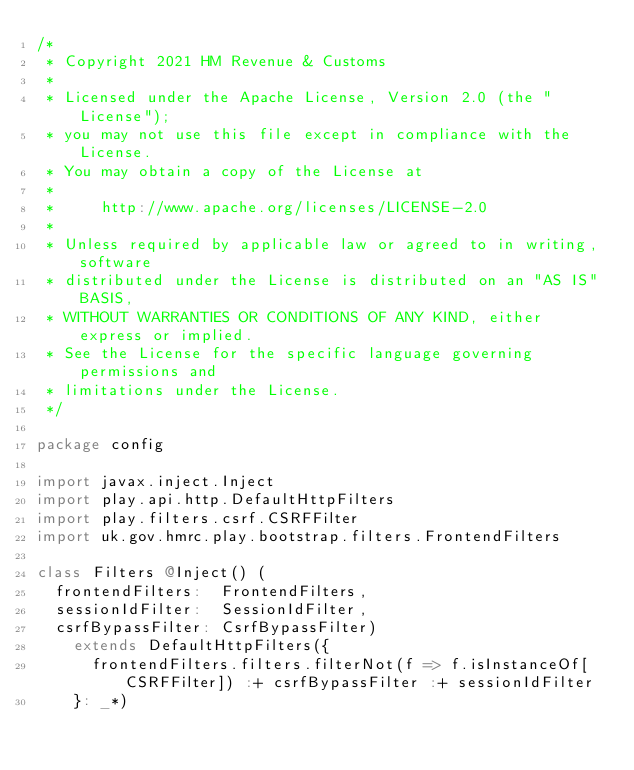<code> <loc_0><loc_0><loc_500><loc_500><_Scala_>/*
 * Copyright 2021 HM Revenue & Customs
 *
 * Licensed under the Apache License, Version 2.0 (the "License");
 * you may not use this file except in compliance with the License.
 * You may obtain a copy of the License at
 *
 *     http://www.apache.org/licenses/LICENSE-2.0
 *
 * Unless required by applicable law or agreed to in writing, software
 * distributed under the License is distributed on an "AS IS" BASIS,
 * WITHOUT WARRANTIES OR CONDITIONS OF ANY KIND, either express or implied.
 * See the License for the specific language governing permissions and
 * limitations under the License.
 */

package config

import javax.inject.Inject
import play.api.http.DefaultHttpFilters
import play.filters.csrf.CSRFFilter
import uk.gov.hmrc.play.bootstrap.filters.FrontendFilters

class Filters @Inject() (
  frontendFilters:  FrontendFilters,
  sessionIdFilter:  SessionIdFilter,
  csrfBypassFilter: CsrfBypassFilter)
    extends DefaultHttpFilters({
      frontendFilters.filters.filterNot(f => f.isInstanceOf[CSRFFilter]) :+ csrfBypassFilter :+ sessionIdFilter
    }: _*)
</code> 